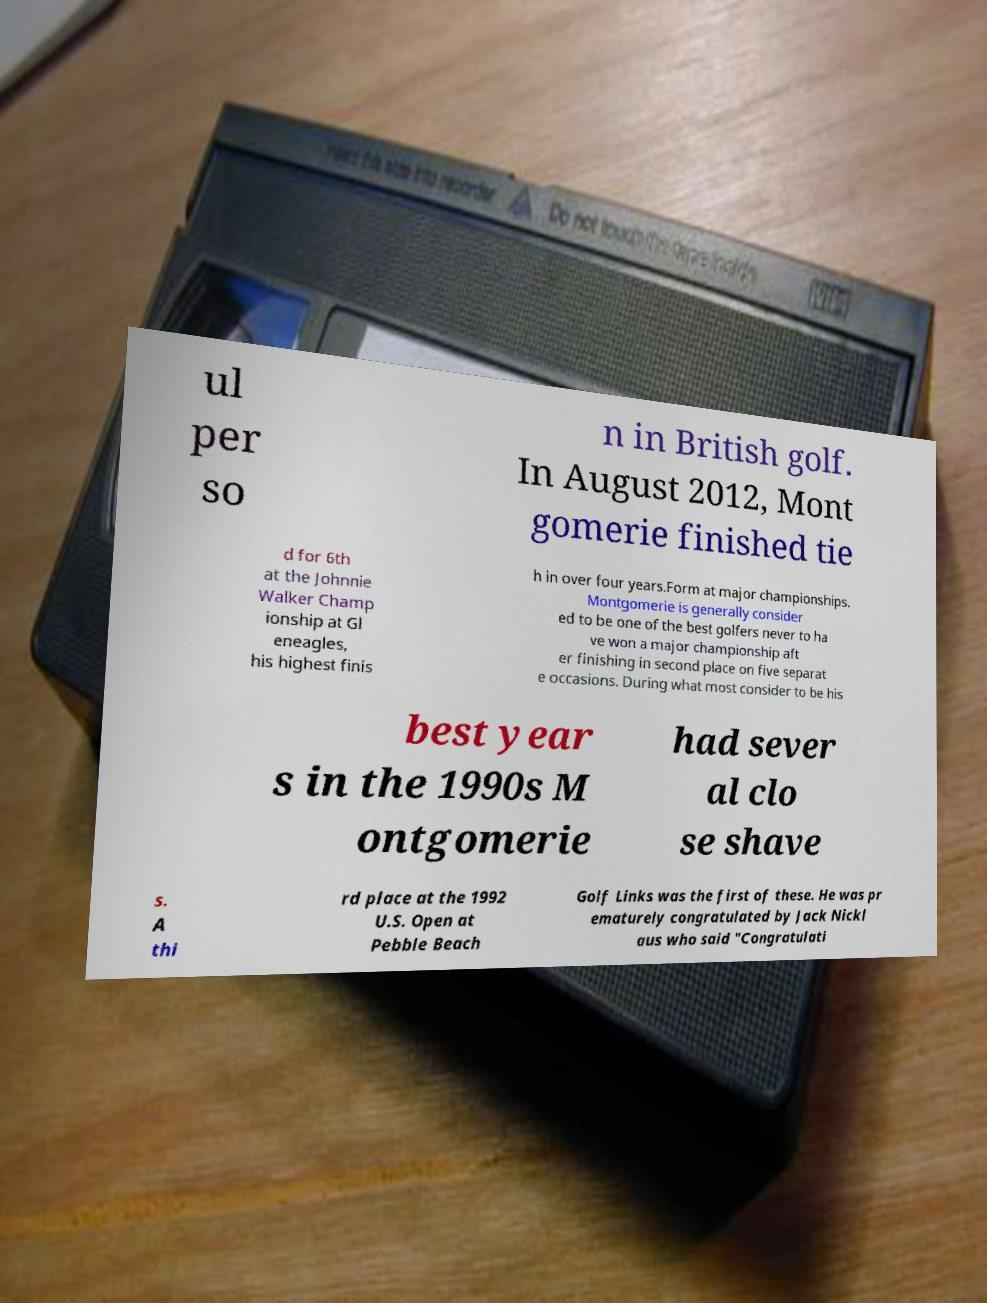Please identify and transcribe the text found in this image. ul per so n in British golf. In August 2012, Mont gomerie finished tie d for 6th at the Johnnie Walker Champ ionship at Gl eneagles, his highest finis h in over four years.Form at major championships. Montgomerie is generally consider ed to be one of the best golfers never to ha ve won a major championship aft er finishing in second place on five separat e occasions. During what most consider to be his best year s in the 1990s M ontgomerie had sever al clo se shave s. A thi rd place at the 1992 U.S. Open at Pebble Beach Golf Links was the first of these. He was pr ematurely congratulated by Jack Nickl aus who said "Congratulati 